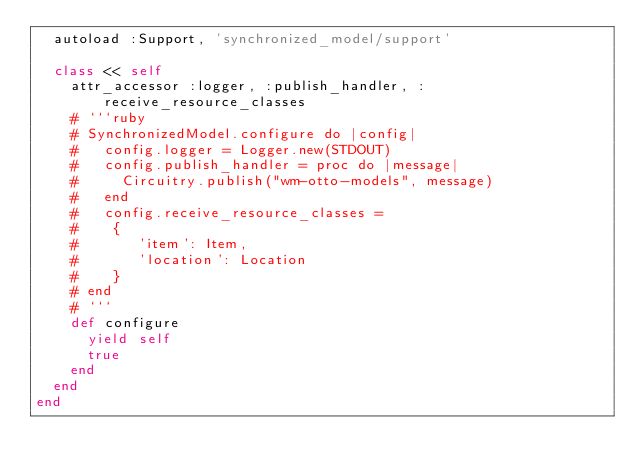<code> <loc_0><loc_0><loc_500><loc_500><_Ruby_>  autoload :Support, 'synchronized_model/support'

  class << self
    attr_accessor :logger, :publish_handler, :receive_resource_classes
    # ```ruby
    # SynchronizedModel.configure do |config|
    #   config.logger = Logger.new(STDOUT)
    #   config.publish_handler = proc do |message|
    #     Circuitry.publish("wm-otto-models", message)
    #   end
    #   config.receive_resource_classes =
    #    {
    #       'item': Item,
    #       'location': Location
    #    }
    # end
    # ```
    def configure
      yield self
      true
    end
  end
end
</code> 